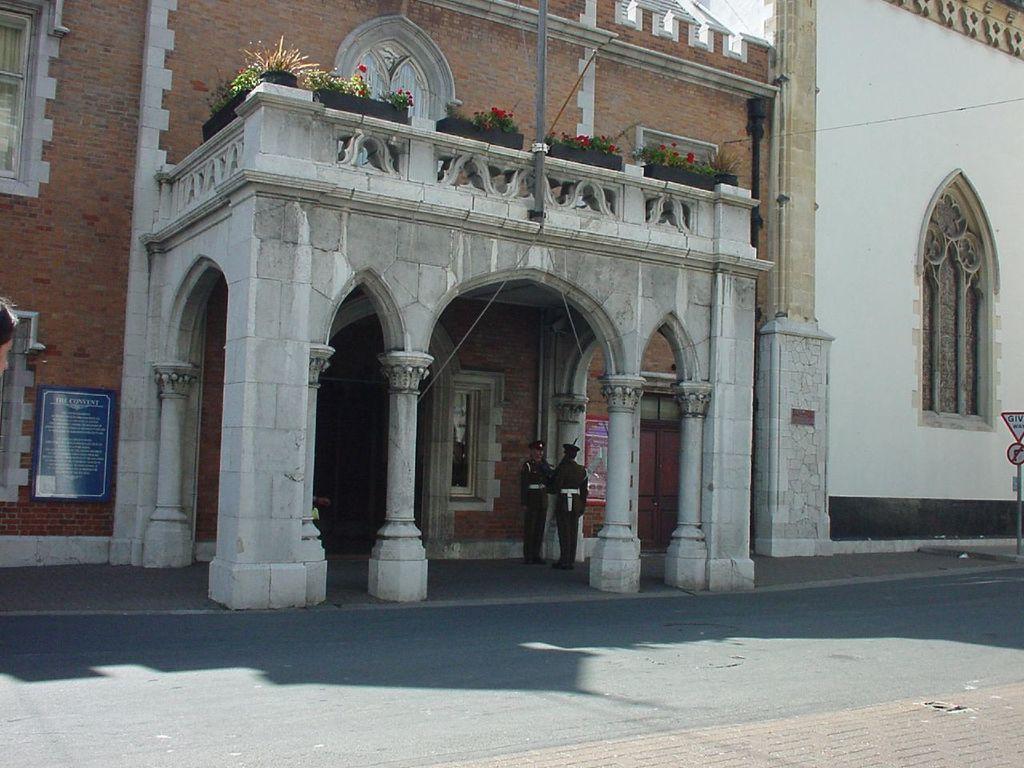In one or two sentences, can you explain what this image depicts? In this picture we can see a building, few plants, flowers and group of people, on the right side of the image we can find few sign boards, on the left side of the image we can find a board on the wall. 